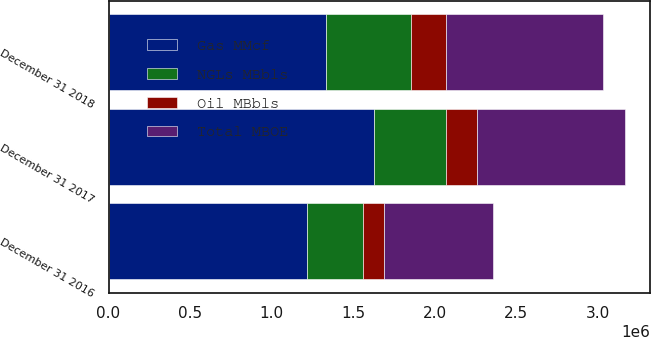<chart> <loc_0><loc_0><loc_500><loc_500><stacked_bar_chart><ecel><fcel>December 31 2018<fcel>December 31 2017<fcel>December 31 2016<nl><fcel>NGLs MBbls<fcel>521579<fcel>442364<fcel>343515<nl><fcel>Oil MBbls<fcel>219730<fcel>189434<fcel>126928<nl><fcel>Gas MMcf<fcel>1.33085e+06<fcel>1.62945e+06<fcel>1.21586e+06<nl><fcel>Total MBOE<fcel>963118<fcel>903373<fcel>673085<nl></chart> 